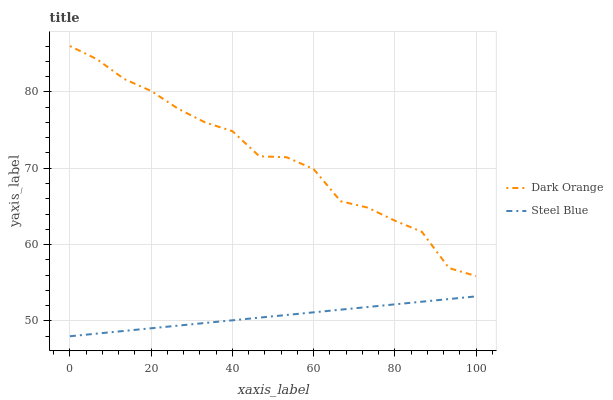Does Steel Blue have the minimum area under the curve?
Answer yes or no. Yes. Does Dark Orange have the maximum area under the curve?
Answer yes or no. Yes. Does Steel Blue have the maximum area under the curve?
Answer yes or no. No. Is Steel Blue the smoothest?
Answer yes or no. Yes. Is Dark Orange the roughest?
Answer yes or no. Yes. Is Steel Blue the roughest?
Answer yes or no. No. Does Steel Blue have the lowest value?
Answer yes or no. Yes. Does Dark Orange have the highest value?
Answer yes or no. Yes. Does Steel Blue have the highest value?
Answer yes or no. No. Is Steel Blue less than Dark Orange?
Answer yes or no. Yes. Is Dark Orange greater than Steel Blue?
Answer yes or no. Yes. Does Steel Blue intersect Dark Orange?
Answer yes or no. No. 